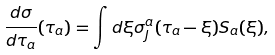<formula> <loc_0><loc_0><loc_500><loc_500>\frac { d \sigma } { d \tau _ { a } } ( \tau _ { a } ) = \int d \xi \sigma _ { J } ^ { a } ( \tau _ { a } - \xi ) S _ { a } ( \xi ) ,</formula> 